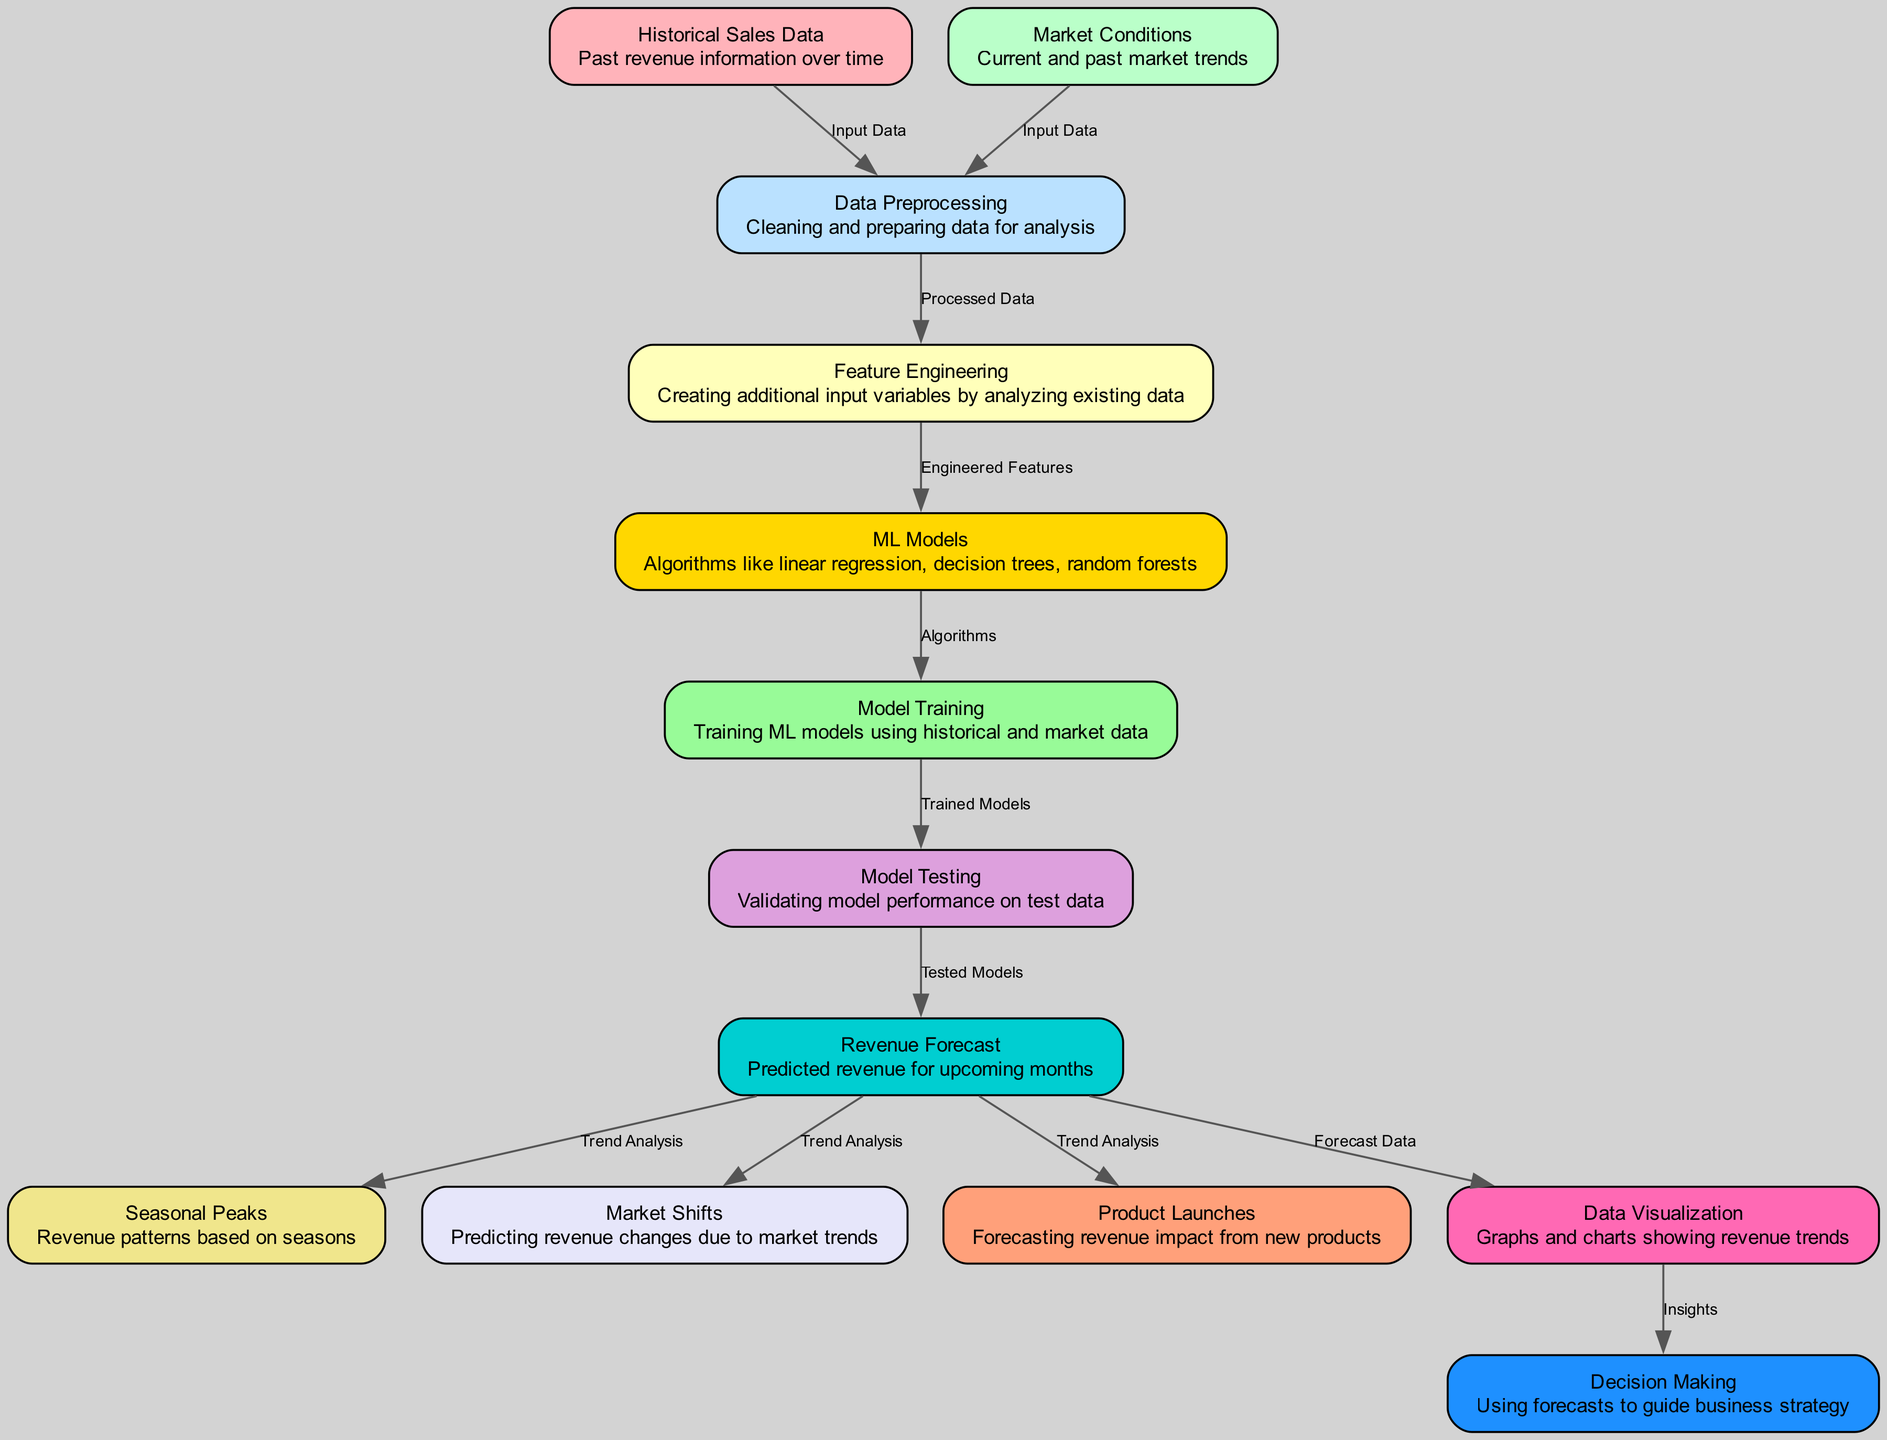What is the starting point for analysis in the diagram? The starting point for analysis is "Historical Sales Data" and "Market Conditions," which are the first two nodes feeding into "Data Preprocessing."
Answer: Historical Sales Data, Market Conditions How many nodes are present in the diagram? A total of 13 nodes are present in the diagram as listed under the data section.
Answer: 13 What type of models are used for revenue prediction? The types of models used for revenue prediction are represented as "ML Models," which include algorithms like linear regression and decision trees.
Answer: ML Models Which node directly follows model training? The node that directly follows "Model Training" is "Model Testing." This relationship is established by the directed edge connecting the two nodes.
Answer: Model Testing What is the primary output of the process depicted in this diagram? The primary output of the process is "Revenue Forecast," which is the end prediction provided by the machine learning models after testing.
Answer: Revenue Forecast How does revenue forecast relate to seasonal peaks? "Revenue Forecast" is linked to "Seasonal Peaks" through a directed edge labeled "Trend Analysis," indicating that the forecast includes analysis of seasonal revenue patterns.
Answer: Trend Analysis Which node represents the step that cleans and prepares data? The node that represents the step that cleans and prepares data is "Data Preprocessing," which follows the input nodes of historical and market data.
Answer: Data Preprocessing What node influences decision making based on insights? The node that influences decision making based on insights is "Visualization," as it provides visual data that supports business strategic choices.
Answer: Visualization How many edges are there between nodes in the diagram? There are 12 edges connected between various nodes as listed in the edges section of the data.
Answer: 12 What does feature engineering create for ML models? Feature engineering creates "Engineered Features" that provide additional input variables based on the existing historical and market data.
Answer: Engineered Features 